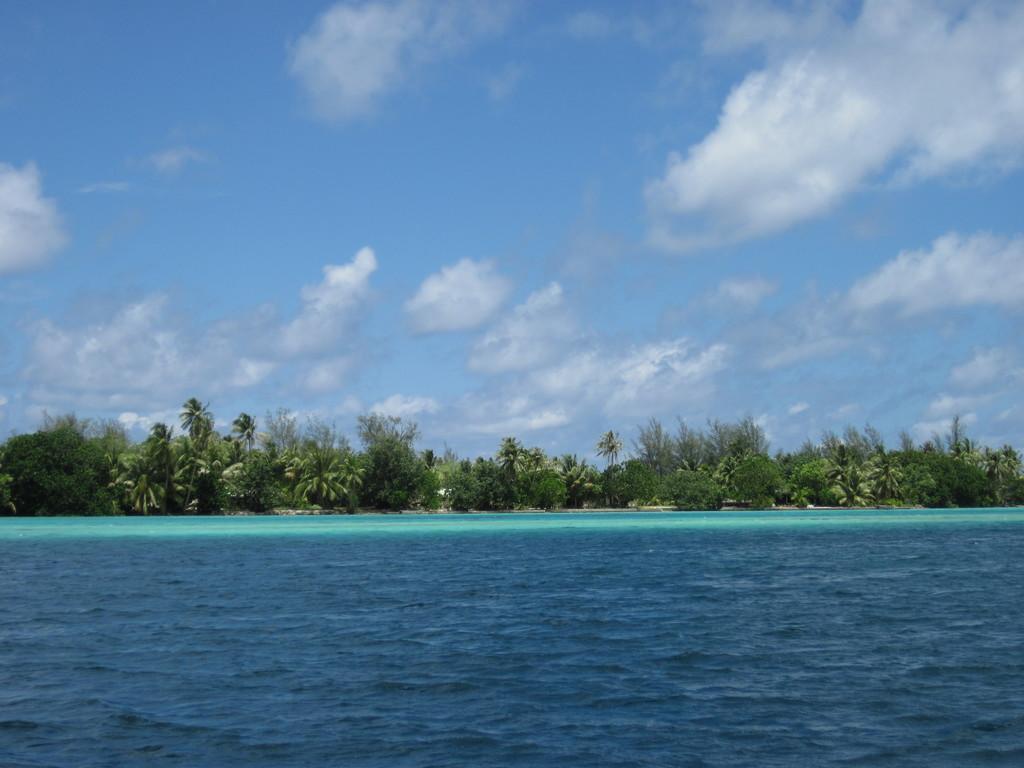Can you describe this image briefly? In the picture I can see trees and the water. In the background of the image I can see the sky. 